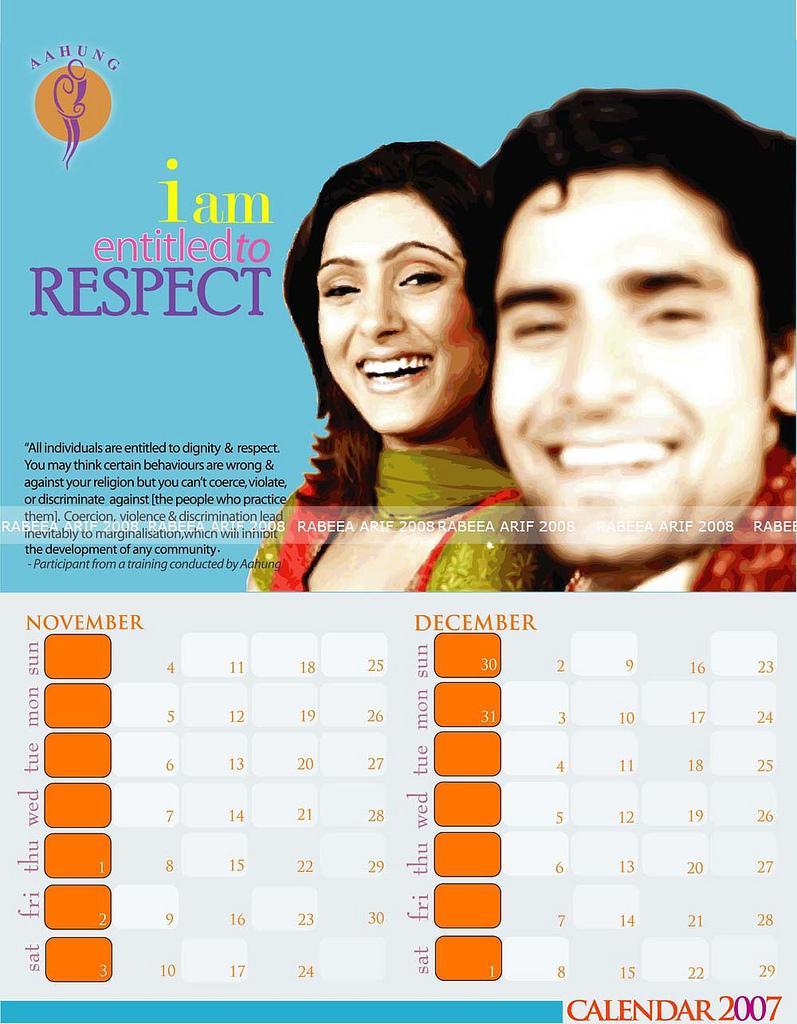In one or two sentences, can you explain what this image depicts? In this image I can see page of a calendar. On the page there are images of two persons, there are words and there are numbers on it. 